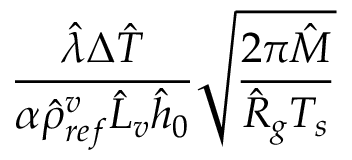Convert formula to latex. <formula><loc_0><loc_0><loc_500><loc_500>\frac { \hat { \lambda } \Delta \hat { T } } { \alpha \hat { \rho } _ { r e f } ^ { v } \hat { L } _ { v } \hat { h } _ { 0 } } \sqrt { \frac { 2 \pi \hat { M } } { \hat { R } _ { g } T _ { s } } }</formula> 